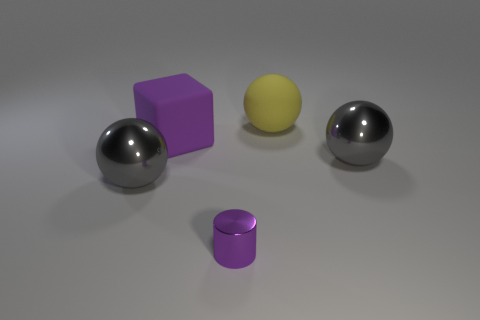What number of other yellow balls are the same material as the big yellow ball?
Ensure brevity in your answer.  0. Are there fewer tiny purple objects to the left of the large block than blue blocks?
Give a very brief answer. No. There is a gray shiny thing that is on the left side of the large gray metallic sphere that is right of the large yellow rubber thing; how big is it?
Your answer should be very brief. Large. Is the color of the small cylinder the same as the matte object that is to the left of the tiny purple cylinder?
Your response must be concise. Yes. What is the material of the purple block that is the same size as the yellow object?
Provide a short and direct response. Rubber. Are there fewer large rubber spheres on the left side of the small metallic cylinder than tiny metal objects that are to the left of the big purple block?
Offer a terse response. No. There is a gray metal thing behind the gray sphere that is left of the yellow rubber ball; what is its shape?
Your response must be concise. Sphere. Are any brown matte objects visible?
Your answer should be compact. No. What is the color of the matte thing to the left of the yellow ball?
Give a very brief answer. Purple. There is a large cube that is the same color as the small cylinder; what material is it?
Keep it short and to the point. Rubber. 